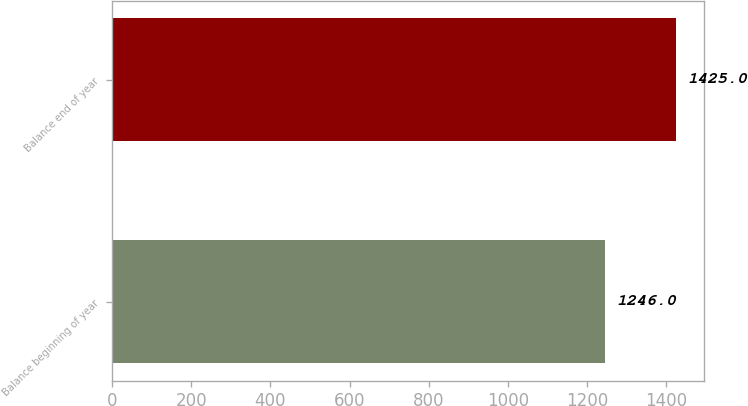Convert chart. <chart><loc_0><loc_0><loc_500><loc_500><bar_chart><fcel>Balance beginning of year<fcel>Balance end of year<nl><fcel>1246<fcel>1425<nl></chart> 